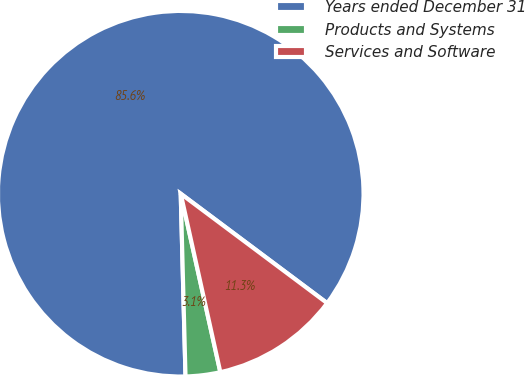Convert chart. <chart><loc_0><loc_0><loc_500><loc_500><pie_chart><fcel>Years ended December 31<fcel>Products and Systems<fcel>Services and Software<nl><fcel>85.63%<fcel>3.06%<fcel>11.31%<nl></chart> 